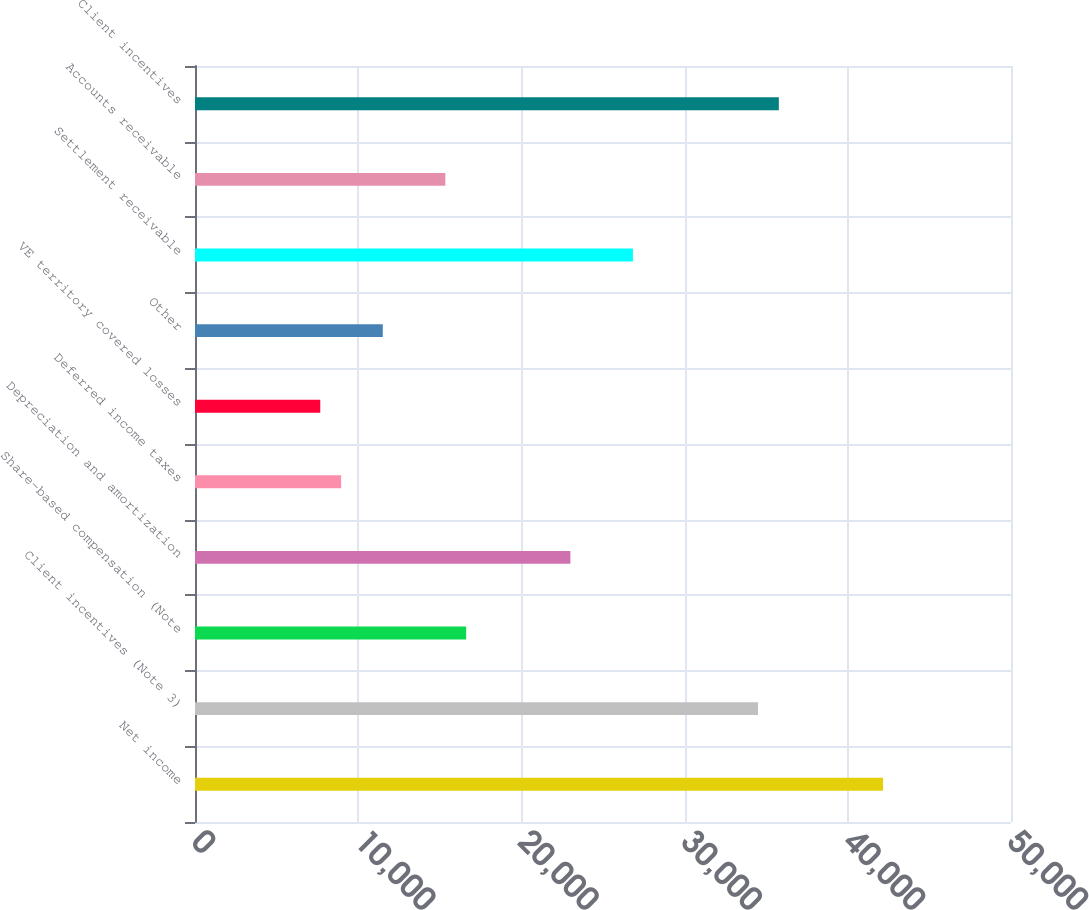Convert chart to OTSL. <chart><loc_0><loc_0><loc_500><loc_500><bar_chart><fcel>Net income<fcel>Client incentives (Note 3)<fcel>Share-based compensation (Note<fcel>Depreciation and amortization<fcel>Deferred income taxes<fcel>VE territory covered losses<fcel>Other<fcel>Settlement receivable<fcel>Accounts receivable<fcel>Client incentives<nl><fcel>42159.6<fcel>34496.4<fcel>16615.6<fcel>23001.6<fcel>8952.4<fcel>7675.2<fcel>11506.8<fcel>26833.2<fcel>15338.4<fcel>35773.6<nl></chart> 